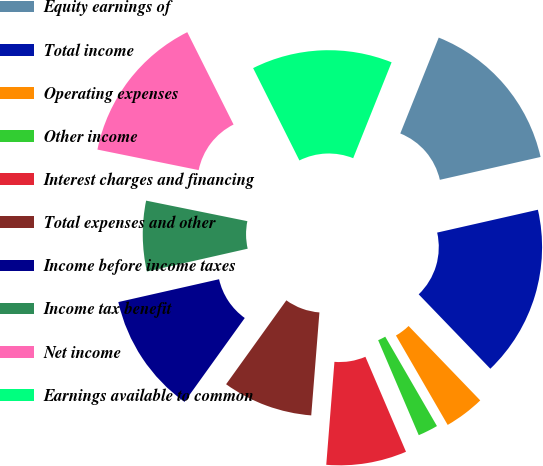Convert chart to OTSL. <chart><loc_0><loc_0><loc_500><loc_500><pie_chart><fcel>Equity earnings of<fcel>Total income<fcel>Operating expenses<fcel>Other income<fcel>Interest charges and financing<fcel>Total expenses and other<fcel>Income before income taxes<fcel>Income tax benefit<fcel>Net income<fcel>Earnings available to common<nl><fcel>15.38%<fcel>16.35%<fcel>3.85%<fcel>1.92%<fcel>7.69%<fcel>8.65%<fcel>11.54%<fcel>6.73%<fcel>14.42%<fcel>13.46%<nl></chart> 